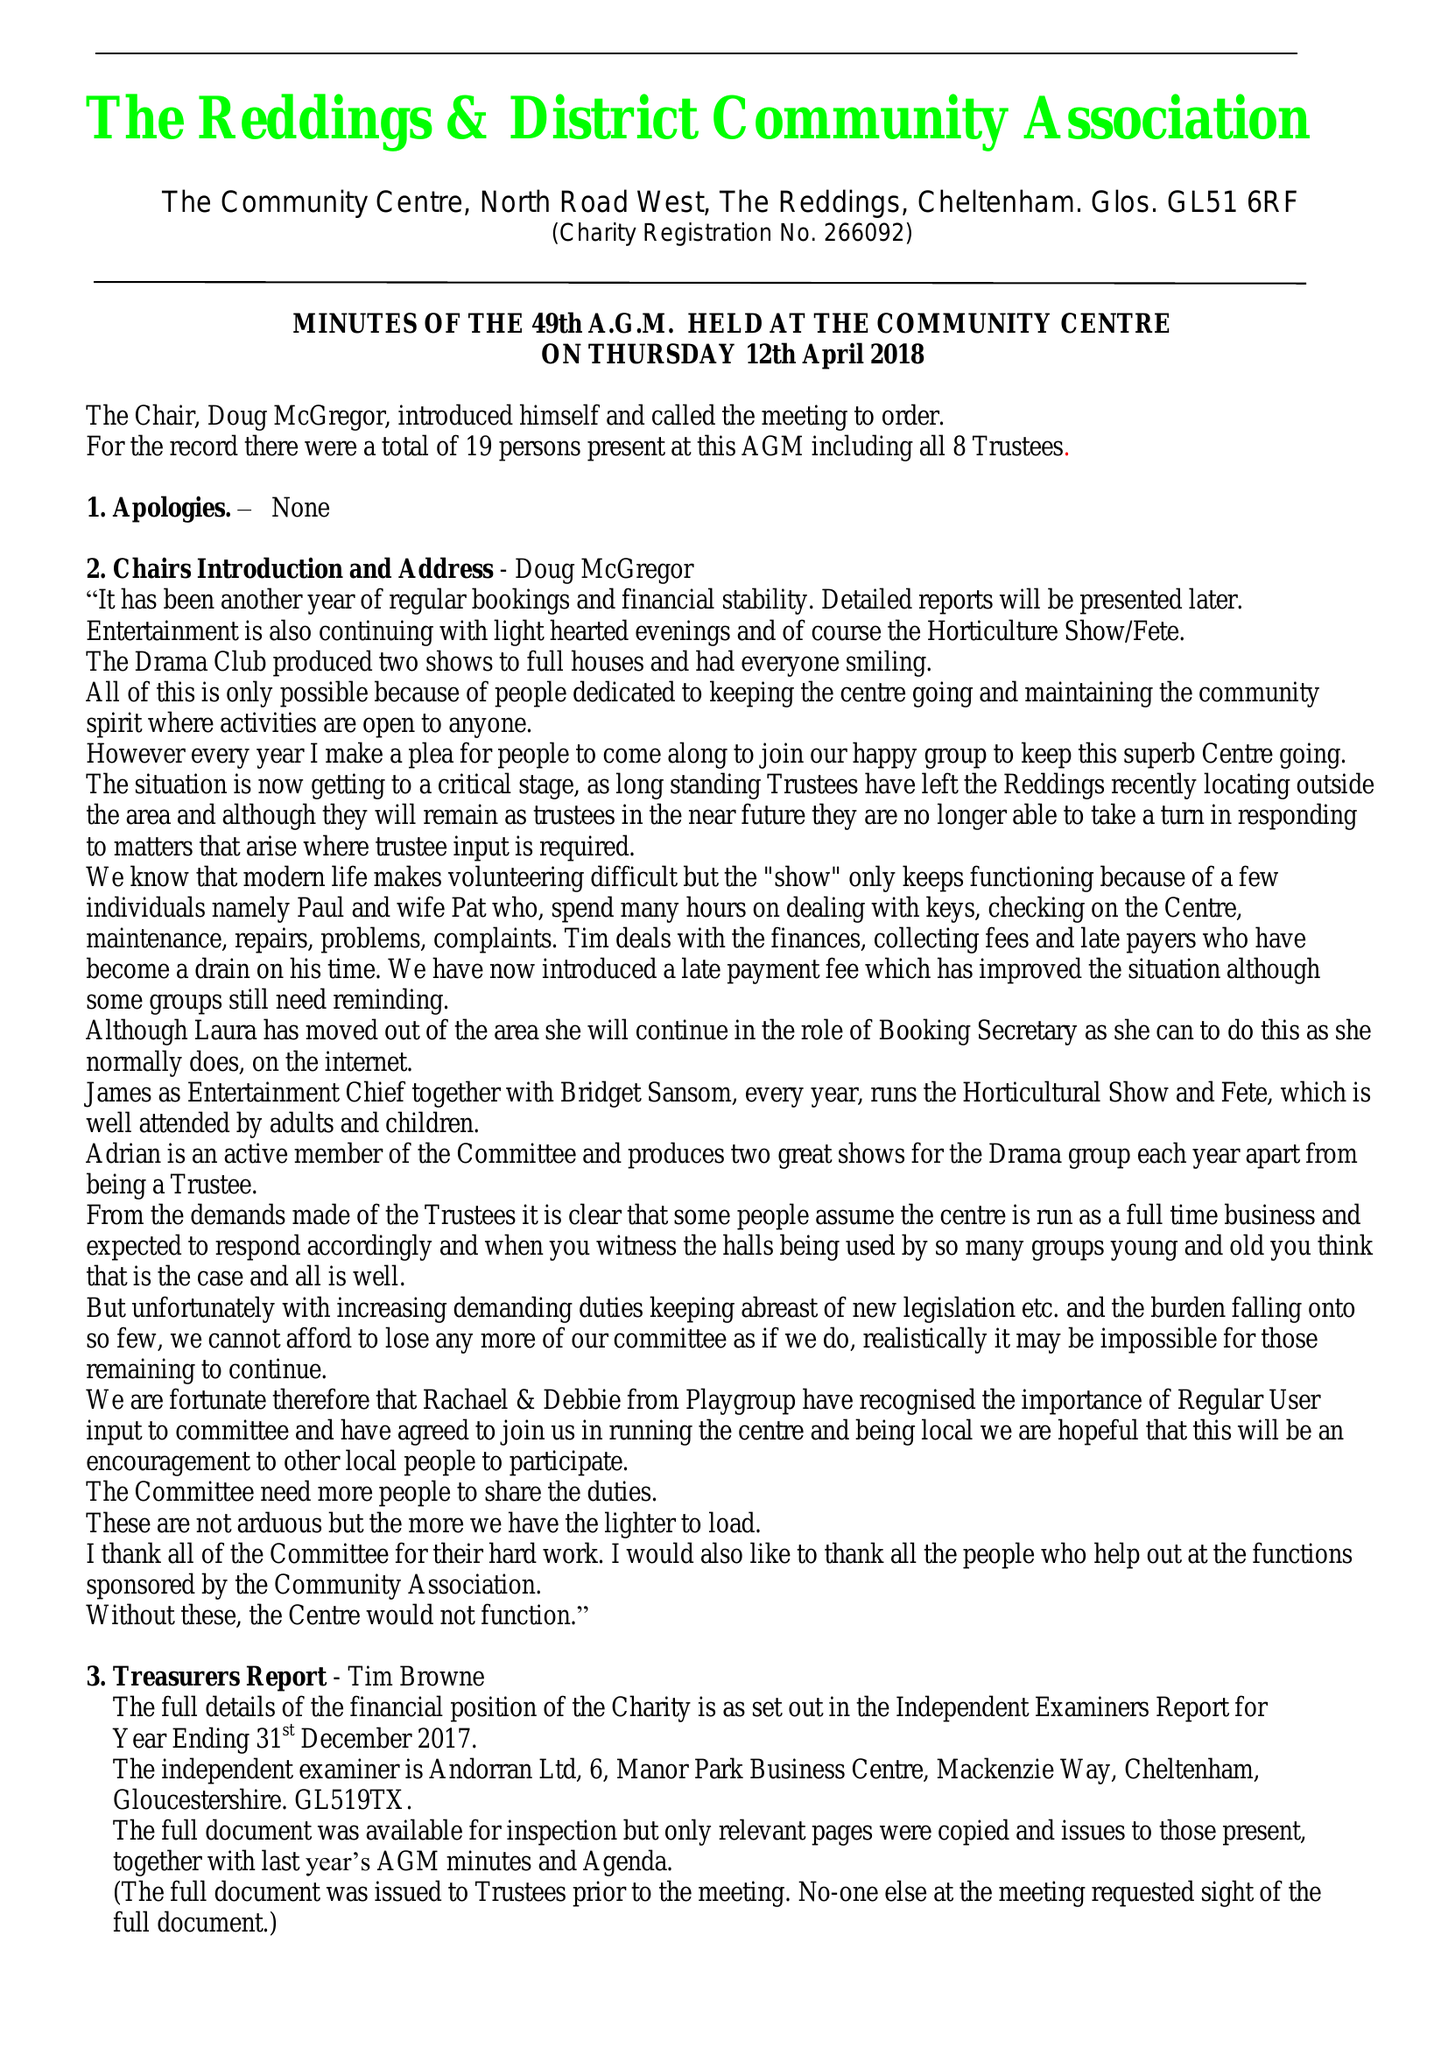What is the value for the report_date?
Answer the question using a single word or phrase. 2017-12-31 